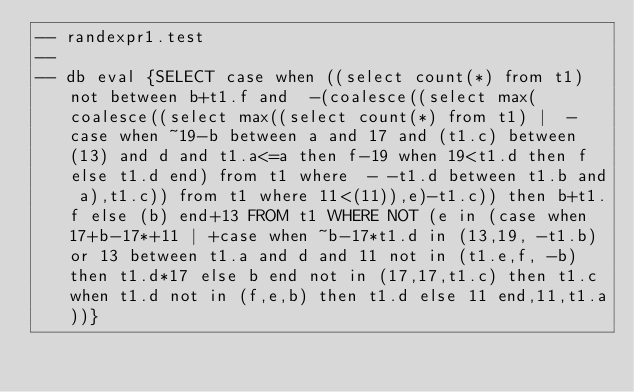Convert code to text. <code><loc_0><loc_0><loc_500><loc_500><_SQL_>-- randexpr1.test
-- 
-- db eval {SELECT case when ((select count(*) from t1) not between b+t1.f and  -(coalesce((select max(coalesce((select max((select count(*) from t1) |  -case when ~19-b between a and 17 and (t1.c) between (13) and d and t1.a<=a then f-19 when 19<t1.d then f else t1.d end) from t1 where  - -t1.d between t1.b and a),t1.c)) from t1 where 11<(11)),e)-t1.c)) then b+t1.f else (b) end+13 FROM t1 WHERE NOT (e in (case when 17+b-17*+11 | +case when ~b-17*t1.d in (13,19, -t1.b) or 13 between t1.a and d and 11 not in (t1.e,f, -b) then t1.d*17 else b end not in (17,17,t1.c) then t1.c when t1.d not in (f,e,b) then t1.d else 11 end,11,t1.a))}</code> 